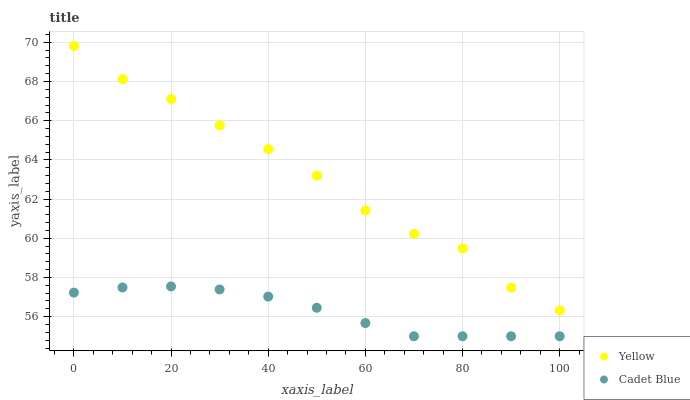Does Cadet Blue have the minimum area under the curve?
Answer yes or no. Yes. Does Yellow have the maximum area under the curve?
Answer yes or no. Yes. Does Yellow have the minimum area under the curve?
Answer yes or no. No. Is Cadet Blue the smoothest?
Answer yes or no. Yes. Is Yellow the roughest?
Answer yes or no. Yes. Is Yellow the smoothest?
Answer yes or no. No. Does Cadet Blue have the lowest value?
Answer yes or no. Yes. Does Yellow have the lowest value?
Answer yes or no. No. Does Yellow have the highest value?
Answer yes or no. Yes. Is Cadet Blue less than Yellow?
Answer yes or no. Yes. Is Yellow greater than Cadet Blue?
Answer yes or no. Yes. Does Cadet Blue intersect Yellow?
Answer yes or no. No. 